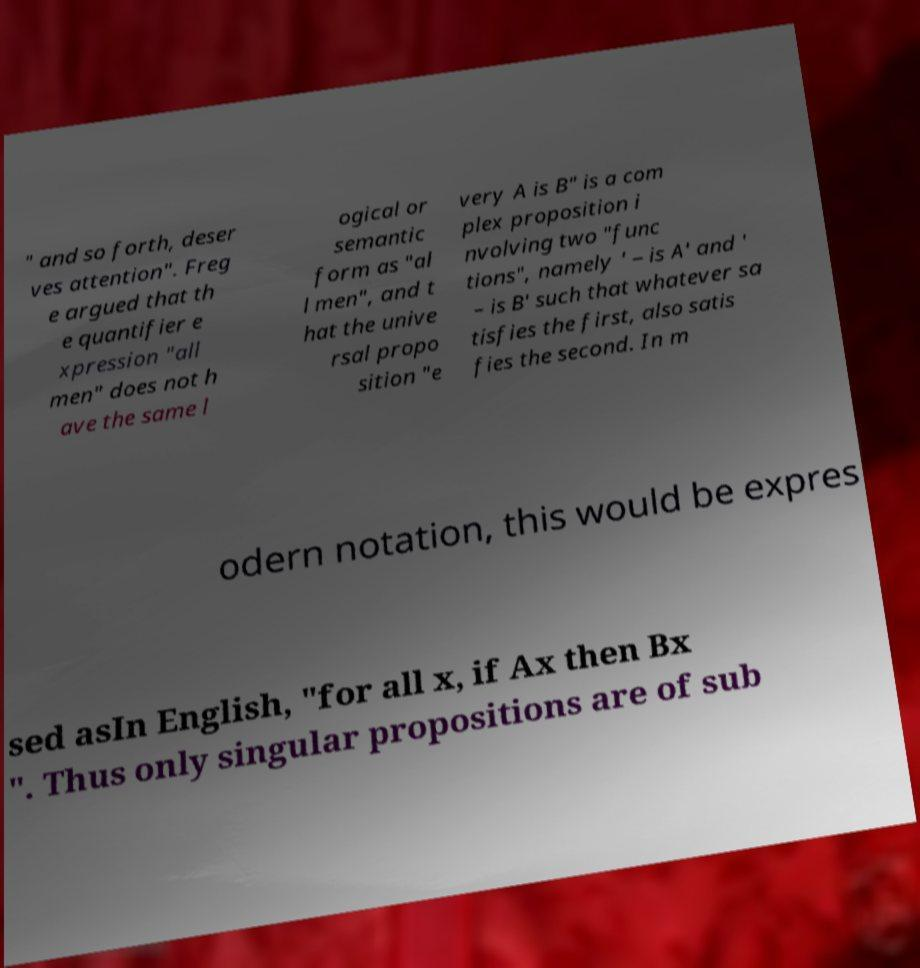Can you accurately transcribe the text from the provided image for me? " and so forth, deser ves attention". Freg e argued that th e quantifier e xpression "all men" does not h ave the same l ogical or semantic form as "al l men", and t hat the unive rsal propo sition "e very A is B" is a com plex proposition i nvolving two "func tions", namely ' – is A' and ' – is B' such that whatever sa tisfies the first, also satis fies the second. In m odern notation, this would be expres sed asIn English, "for all x, if Ax then Bx ". Thus only singular propositions are of sub 